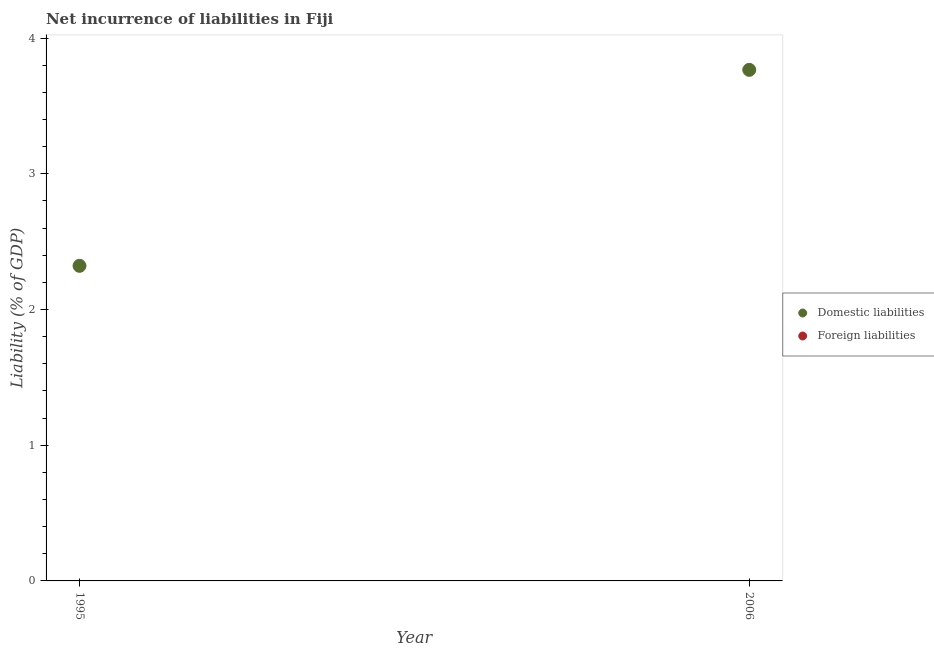Across all years, what is the maximum incurrence of domestic liabilities?
Make the answer very short. 3.77. In which year was the incurrence of domestic liabilities maximum?
Provide a short and direct response. 2006. What is the total incurrence of foreign liabilities in the graph?
Your answer should be compact. 0. What is the difference between the incurrence of domestic liabilities in 1995 and that in 2006?
Provide a succinct answer. -1.44. What is the difference between the incurrence of foreign liabilities in 2006 and the incurrence of domestic liabilities in 1995?
Offer a terse response. -2.32. In how many years, is the incurrence of domestic liabilities greater than 1 %?
Your answer should be compact. 2. What is the ratio of the incurrence of domestic liabilities in 1995 to that in 2006?
Offer a terse response. 0.62. Is the incurrence of domestic liabilities in 1995 less than that in 2006?
Provide a short and direct response. Yes. Does the incurrence of domestic liabilities monotonically increase over the years?
Provide a succinct answer. Yes. How many years are there in the graph?
Provide a short and direct response. 2. What is the difference between two consecutive major ticks on the Y-axis?
Your response must be concise. 1. Are the values on the major ticks of Y-axis written in scientific E-notation?
Your answer should be compact. No. Where does the legend appear in the graph?
Your answer should be very brief. Center right. How many legend labels are there?
Provide a short and direct response. 2. How are the legend labels stacked?
Your response must be concise. Vertical. What is the title of the graph?
Provide a succinct answer. Net incurrence of liabilities in Fiji. Does "Resident" appear as one of the legend labels in the graph?
Your answer should be compact. No. What is the label or title of the X-axis?
Your response must be concise. Year. What is the label or title of the Y-axis?
Keep it short and to the point. Liability (% of GDP). What is the Liability (% of GDP) in Domestic liabilities in 1995?
Provide a short and direct response. 2.32. What is the Liability (% of GDP) of Foreign liabilities in 1995?
Make the answer very short. 0. What is the Liability (% of GDP) of Domestic liabilities in 2006?
Provide a succinct answer. 3.77. What is the Liability (% of GDP) of Foreign liabilities in 2006?
Your response must be concise. 0. Across all years, what is the maximum Liability (% of GDP) in Domestic liabilities?
Your answer should be very brief. 3.77. Across all years, what is the minimum Liability (% of GDP) of Domestic liabilities?
Your answer should be compact. 2.32. What is the total Liability (% of GDP) of Domestic liabilities in the graph?
Make the answer very short. 6.09. What is the total Liability (% of GDP) of Foreign liabilities in the graph?
Provide a succinct answer. 0. What is the difference between the Liability (% of GDP) of Domestic liabilities in 1995 and that in 2006?
Your answer should be compact. -1.44. What is the average Liability (% of GDP) of Domestic liabilities per year?
Provide a short and direct response. 3.04. What is the ratio of the Liability (% of GDP) of Domestic liabilities in 1995 to that in 2006?
Ensure brevity in your answer.  0.62. What is the difference between the highest and the second highest Liability (% of GDP) in Domestic liabilities?
Ensure brevity in your answer.  1.44. What is the difference between the highest and the lowest Liability (% of GDP) of Domestic liabilities?
Ensure brevity in your answer.  1.44. 